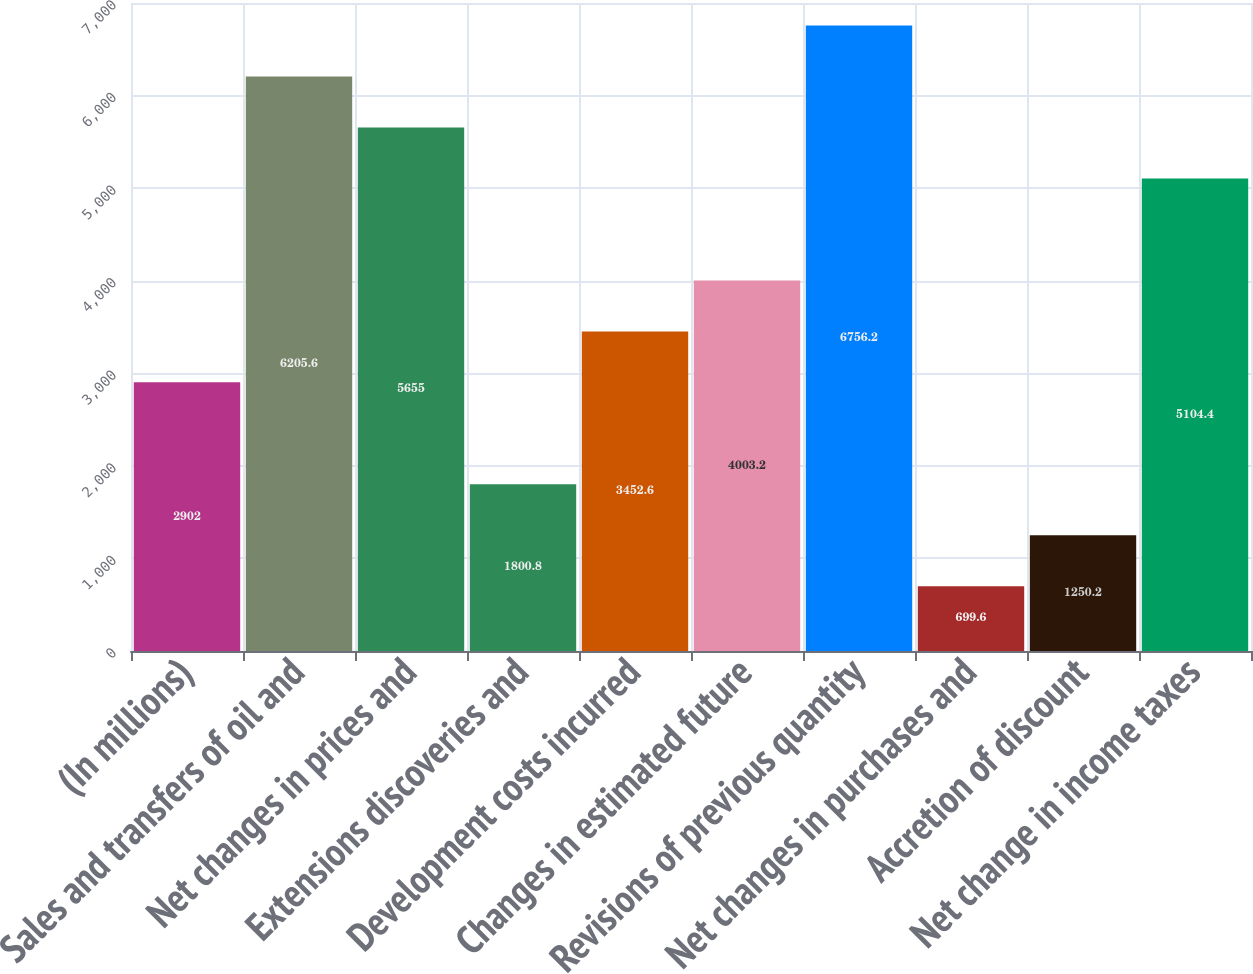Convert chart to OTSL. <chart><loc_0><loc_0><loc_500><loc_500><bar_chart><fcel>(In millions)<fcel>Sales and transfers of oil and<fcel>Net changes in prices and<fcel>Extensions discoveries and<fcel>Development costs incurred<fcel>Changes in estimated future<fcel>Revisions of previous quantity<fcel>Net changes in purchases and<fcel>Accretion of discount<fcel>Net change in income taxes<nl><fcel>2902<fcel>6205.6<fcel>5655<fcel>1800.8<fcel>3452.6<fcel>4003.2<fcel>6756.2<fcel>699.6<fcel>1250.2<fcel>5104.4<nl></chart> 